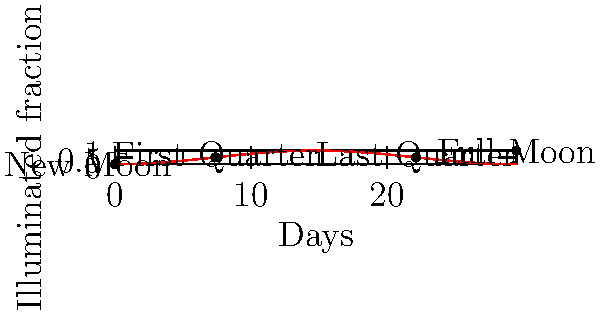As a tour guide in Kinshasa, you're often asked about celestial events. Using the lunar phase diagram, calculate the number of days between the New Moon and the First Quarter Moon. How might this information be useful for planning night-time tours in the Democratic Republic of the Congo? To solve this question, we need to follow these steps:

1. Understand the lunar phase diagram:
   - The x-axis represents days in the lunar cycle
   - The y-axis represents the illuminated fraction of the Moon
   - The curve shows how the illuminated fraction changes over time

2. Identify the points for New Moon and First Quarter Moon:
   - New Moon occurs at (0,0) on the graph
   - First Quarter Moon occurs when the illuminated fraction is 0.5

3. Find the x-coordinate (day) of the First Quarter Moon:
   - From the graph, we can see this occurs at approximately 7.38 days

4. Calculate the difference:
   $7.38 - 0 = 7.38$ days

5. Relevance to tour planning in DRC:
   - Knowing the Moon's phases helps predict nighttime visibility
   - First Quarter Moon provides some illumination without washing out the night sky
   - This can be ideal for night safaris or stargazing tours
   - The 7-day cycle allows for weekly planning of moonlit or dark-sky activities
   - In Kinshasa, this information can be used to schedule evening boat tours on the Congo River or night walks in nearby nature reserves
Answer: 7.38 days; allows weekly planning of night tours based on moonlight conditions 